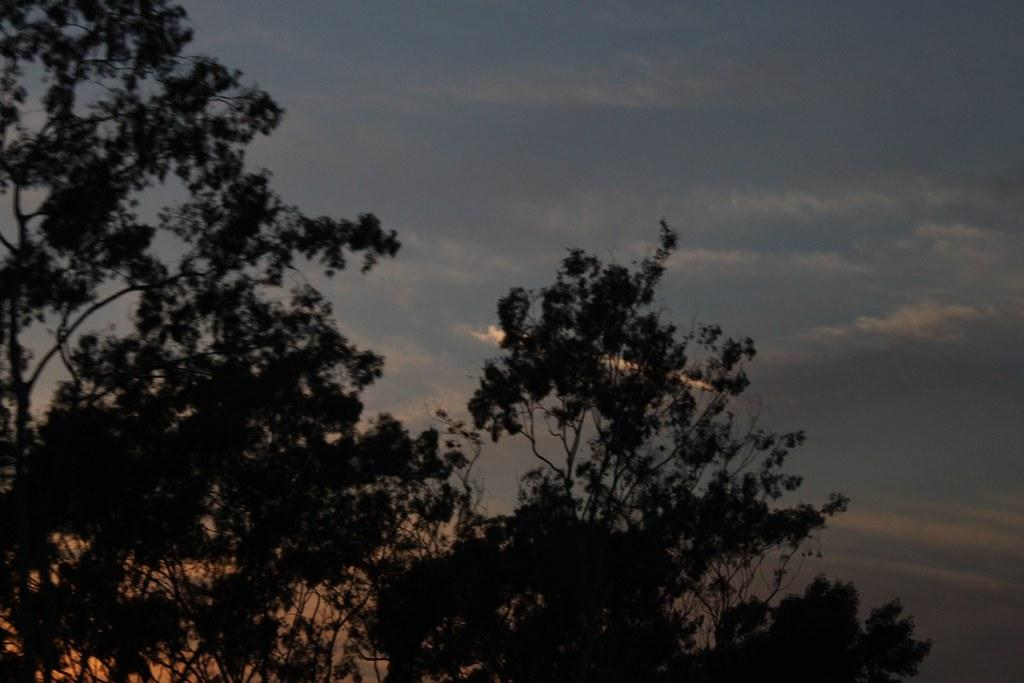What type of setting is depicted in the image? The image is an outside view. What can be seen in the image besides the sky? There are many trees in the image. What is visible at the top of the image? The sky is visible at the top of the image. What can be observed in the sky? Clouds are present in the sky. What type of behavior does the sister exhibit in the image? There is no sister present in the image, so it is not possible to comment on her behavior. 